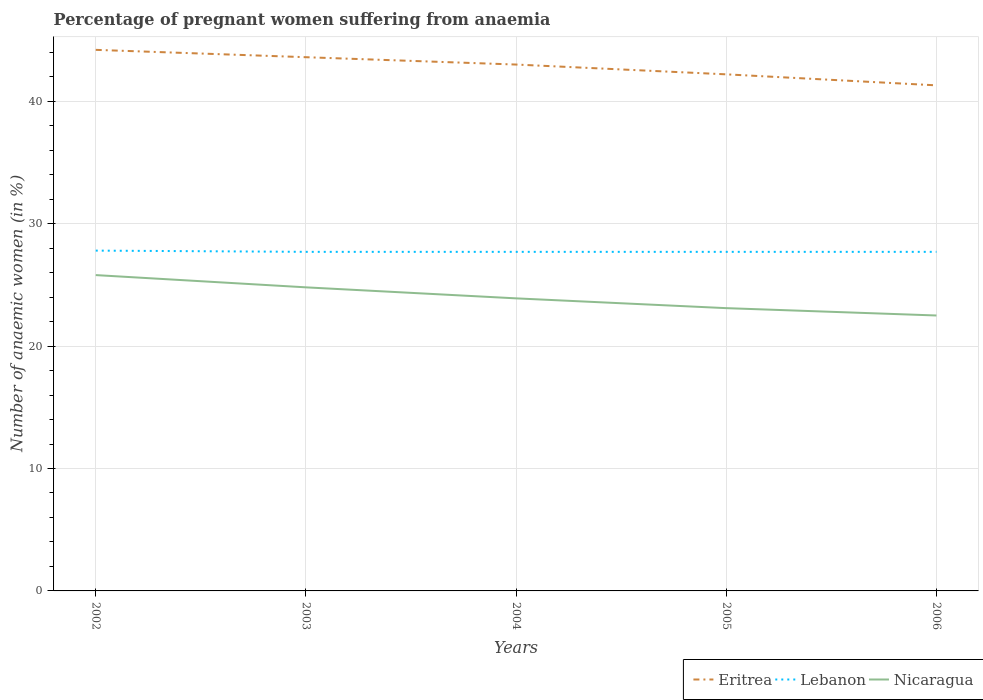Does the line corresponding to Nicaragua intersect with the line corresponding to Lebanon?
Your response must be concise. No. Is the number of lines equal to the number of legend labels?
Your answer should be very brief. Yes. Across all years, what is the maximum number of anaemic women in Eritrea?
Give a very brief answer. 41.3. In which year was the number of anaemic women in Nicaragua maximum?
Your response must be concise. 2006. What is the total number of anaemic women in Lebanon in the graph?
Give a very brief answer. 0.1. What is the difference between the highest and the second highest number of anaemic women in Lebanon?
Provide a short and direct response. 0.1. What is the difference between the highest and the lowest number of anaemic women in Lebanon?
Offer a terse response. 1. Is the number of anaemic women in Lebanon strictly greater than the number of anaemic women in Eritrea over the years?
Your answer should be compact. Yes. How many lines are there?
Ensure brevity in your answer.  3. How many legend labels are there?
Offer a very short reply. 3. What is the title of the graph?
Your response must be concise. Percentage of pregnant women suffering from anaemia. Does "Montenegro" appear as one of the legend labels in the graph?
Your answer should be compact. No. What is the label or title of the Y-axis?
Your response must be concise. Number of anaemic women (in %). What is the Number of anaemic women (in %) of Eritrea in 2002?
Offer a very short reply. 44.2. What is the Number of anaemic women (in %) in Lebanon in 2002?
Keep it short and to the point. 27.8. What is the Number of anaemic women (in %) of Nicaragua in 2002?
Give a very brief answer. 25.8. What is the Number of anaemic women (in %) in Eritrea in 2003?
Give a very brief answer. 43.6. What is the Number of anaemic women (in %) in Lebanon in 2003?
Provide a short and direct response. 27.7. What is the Number of anaemic women (in %) of Nicaragua in 2003?
Give a very brief answer. 24.8. What is the Number of anaemic women (in %) of Lebanon in 2004?
Offer a very short reply. 27.7. What is the Number of anaemic women (in %) in Nicaragua in 2004?
Offer a very short reply. 23.9. What is the Number of anaemic women (in %) of Eritrea in 2005?
Your answer should be compact. 42.2. What is the Number of anaemic women (in %) in Lebanon in 2005?
Your answer should be compact. 27.7. What is the Number of anaemic women (in %) in Nicaragua in 2005?
Provide a succinct answer. 23.1. What is the Number of anaemic women (in %) in Eritrea in 2006?
Ensure brevity in your answer.  41.3. What is the Number of anaemic women (in %) in Lebanon in 2006?
Your answer should be very brief. 27.7. What is the Number of anaemic women (in %) of Nicaragua in 2006?
Provide a short and direct response. 22.5. Across all years, what is the maximum Number of anaemic women (in %) of Eritrea?
Offer a very short reply. 44.2. Across all years, what is the maximum Number of anaemic women (in %) of Lebanon?
Your response must be concise. 27.8. Across all years, what is the maximum Number of anaemic women (in %) in Nicaragua?
Provide a succinct answer. 25.8. Across all years, what is the minimum Number of anaemic women (in %) in Eritrea?
Provide a succinct answer. 41.3. Across all years, what is the minimum Number of anaemic women (in %) of Lebanon?
Provide a short and direct response. 27.7. What is the total Number of anaemic women (in %) in Eritrea in the graph?
Offer a very short reply. 214.3. What is the total Number of anaemic women (in %) in Lebanon in the graph?
Provide a succinct answer. 138.6. What is the total Number of anaemic women (in %) of Nicaragua in the graph?
Keep it short and to the point. 120.1. What is the difference between the Number of anaemic women (in %) in Eritrea in 2002 and that in 2003?
Your answer should be compact. 0.6. What is the difference between the Number of anaemic women (in %) in Nicaragua in 2002 and that in 2003?
Your answer should be very brief. 1. What is the difference between the Number of anaemic women (in %) in Eritrea in 2002 and that in 2004?
Make the answer very short. 1.2. What is the difference between the Number of anaemic women (in %) of Nicaragua in 2002 and that in 2004?
Your response must be concise. 1.9. What is the difference between the Number of anaemic women (in %) of Nicaragua in 2002 and that in 2005?
Your response must be concise. 2.7. What is the difference between the Number of anaemic women (in %) in Eritrea in 2002 and that in 2006?
Keep it short and to the point. 2.9. What is the difference between the Number of anaemic women (in %) in Lebanon in 2002 and that in 2006?
Provide a short and direct response. 0.1. What is the difference between the Number of anaemic women (in %) in Nicaragua in 2002 and that in 2006?
Your answer should be very brief. 3.3. What is the difference between the Number of anaemic women (in %) of Eritrea in 2003 and that in 2004?
Offer a very short reply. 0.6. What is the difference between the Number of anaemic women (in %) in Nicaragua in 2003 and that in 2004?
Offer a very short reply. 0.9. What is the difference between the Number of anaemic women (in %) of Lebanon in 2003 and that in 2005?
Your answer should be very brief. 0. What is the difference between the Number of anaemic women (in %) of Nicaragua in 2004 and that in 2005?
Offer a terse response. 0.8. What is the difference between the Number of anaemic women (in %) of Eritrea in 2004 and that in 2006?
Give a very brief answer. 1.7. What is the difference between the Number of anaemic women (in %) of Lebanon in 2004 and that in 2006?
Your answer should be compact. 0. What is the difference between the Number of anaemic women (in %) of Eritrea in 2005 and that in 2006?
Provide a short and direct response. 0.9. What is the difference between the Number of anaemic women (in %) in Lebanon in 2005 and that in 2006?
Offer a terse response. 0. What is the difference between the Number of anaemic women (in %) in Nicaragua in 2005 and that in 2006?
Make the answer very short. 0.6. What is the difference between the Number of anaemic women (in %) in Eritrea in 2002 and the Number of anaemic women (in %) in Nicaragua in 2003?
Keep it short and to the point. 19.4. What is the difference between the Number of anaemic women (in %) in Lebanon in 2002 and the Number of anaemic women (in %) in Nicaragua in 2003?
Make the answer very short. 3. What is the difference between the Number of anaemic women (in %) in Eritrea in 2002 and the Number of anaemic women (in %) in Lebanon in 2004?
Your answer should be compact. 16.5. What is the difference between the Number of anaemic women (in %) of Eritrea in 2002 and the Number of anaemic women (in %) of Nicaragua in 2004?
Your response must be concise. 20.3. What is the difference between the Number of anaemic women (in %) of Lebanon in 2002 and the Number of anaemic women (in %) of Nicaragua in 2004?
Offer a very short reply. 3.9. What is the difference between the Number of anaemic women (in %) of Eritrea in 2002 and the Number of anaemic women (in %) of Nicaragua in 2005?
Your answer should be compact. 21.1. What is the difference between the Number of anaemic women (in %) in Lebanon in 2002 and the Number of anaemic women (in %) in Nicaragua in 2005?
Make the answer very short. 4.7. What is the difference between the Number of anaemic women (in %) of Eritrea in 2002 and the Number of anaemic women (in %) of Nicaragua in 2006?
Keep it short and to the point. 21.7. What is the difference between the Number of anaemic women (in %) of Lebanon in 2002 and the Number of anaemic women (in %) of Nicaragua in 2006?
Provide a succinct answer. 5.3. What is the difference between the Number of anaemic women (in %) in Eritrea in 2003 and the Number of anaemic women (in %) in Lebanon in 2004?
Give a very brief answer. 15.9. What is the difference between the Number of anaemic women (in %) in Eritrea in 2003 and the Number of anaemic women (in %) in Nicaragua in 2004?
Give a very brief answer. 19.7. What is the difference between the Number of anaemic women (in %) in Lebanon in 2003 and the Number of anaemic women (in %) in Nicaragua in 2004?
Offer a very short reply. 3.8. What is the difference between the Number of anaemic women (in %) in Eritrea in 2003 and the Number of anaemic women (in %) in Lebanon in 2005?
Your answer should be compact. 15.9. What is the difference between the Number of anaemic women (in %) in Lebanon in 2003 and the Number of anaemic women (in %) in Nicaragua in 2005?
Offer a terse response. 4.6. What is the difference between the Number of anaemic women (in %) in Eritrea in 2003 and the Number of anaemic women (in %) in Nicaragua in 2006?
Your answer should be compact. 21.1. What is the difference between the Number of anaemic women (in %) in Lebanon in 2003 and the Number of anaemic women (in %) in Nicaragua in 2006?
Provide a short and direct response. 5.2. What is the difference between the Number of anaemic women (in %) in Eritrea in 2004 and the Number of anaemic women (in %) in Lebanon in 2005?
Your answer should be compact. 15.3. What is the difference between the Number of anaemic women (in %) in Eritrea in 2004 and the Number of anaemic women (in %) in Nicaragua in 2005?
Keep it short and to the point. 19.9. What is the difference between the Number of anaemic women (in %) in Lebanon in 2005 and the Number of anaemic women (in %) in Nicaragua in 2006?
Your answer should be compact. 5.2. What is the average Number of anaemic women (in %) in Eritrea per year?
Your answer should be compact. 42.86. What is the average Number of anaemic women (in %) of Lebanon per year?
Your answer should be very brief. 27.72. What is the average Number of anaemic women (in %) of Nicaragua per year?
Your answer should be very brief. 24.02. In the year 2002, what is the difference between the Number of anaemic women (in %) in Eritrea and Number of anaemic women (in %) in Lebanon?
Offer a very short reply. 16.4. In the year 2002, what is the difference between the Number of anaemic women (in %) of Lebanon and Number of anaemic women (in %) of Nicaragua?
Provide a short and direct response. 2. In the year 2003, what is the difference between the Number of anaemic women (in %) in Eritrea and Number of anaemic women (in %) in Nicaragua?
Provide a succinct answer. 18.8. In the year 2003, what is the difference between the Number of anaemic women (in %) in Lebanon and Number of anaemic women (in %) in Nicaragua?
Your answer should be very brief. 2.9. In the year 2004, what is the difference between the Number of anaemic women (in %) of Lebanon and Number of anaemic women (in %) of Nicaragua?
Provide a succinct answer. 3.8. In the year 2006, what is the difference between the Number of anaemic women (in %) of Eritrea and Number of anaemic women (in %) of Lebanon?
Your response must be concise. 13.6. In the year 2006, what is the difference between the Number of anaemic women (in %) of Eritrea and Number of anaemic women (in %) of Nicaragua?
Offer a terse response. 18.8. What is the ratio of the Number of anaemic women (in %) of Eritrea in 2002 to that in 2003?
Make the answer very short. 1.01. What is the ratio of the Number of anaemic women (in %) of Nicaragua in 2002 to that in 2003?
Your answer should be compact. 1.04. What is the ratio of the Number of anaemic women (in %) of Eritrea in 2002 to that in 2004?
Make the answer very short. 1.03. What is the ratio of the Number of anaemic women (in %) in Lebanon in 2002 to that in 2004?
Offer a terse response. 1. What is the ratio of the Number of anaemic women (in %) in Nicaragua in 2002 to that in 2004?
Provide a short and direct response. 1.08. What is the ratio of the Number of anaemic women (in %) in Eritrea in 2002 to that in 2005?
Give a very brief answer. 1.05. What is the ratio of the Number of anaemic women (in %) in Nicaragua in 2002 to that in 2005?
Make the answer very short. 1.12. What is the ratio of the Number of anaemic women (in %) of Eritrea in 2002 to that in 2006?
Provide a short and direct response. 1.07. What is the ratio of the Number of anaemic women (in %) in Nicaragua in 2002 to that in 2006?
Your response must be concise. 1.15. What is the ratio of the Number of anaemic women (in %) of Lebanon in 2003 to that in 2004?
Offer a terse response. 1. What is the ratio of the Number of anaemic women (in %) in Nicaragua in 2003 to that in 2004?
Make the answer very short. 1.04. What is the ratio of the Number of anaemic women (in %) of Eritrea in 2003 to that in 2005?
Your response must be concise. 1.03. What is the ratio of the Number of anaemic women (in %) of Nicaragua in 2003 to that in 2005?
Offer a very short reply. 1.07. What is the ratio of the Number of anaemic women (in %) of Eritrea in 2003 to that in 2006?
Your answer should be compact. 1.06. What is the ratio of the Number of anaemic women (in %) of Nicaragua in 2003 to that in 2006?
Give a very brief answer. 1.1. What is the ratio of the Number of anaemic women (in %) of Nicaragua in 2004 to that in 2005?
Ensure brevity in your answer.  1.03. What is the ratio of the Number of anaemic women (in %) of Eritrea in 2004 to that in 2006?
Provide a short and direct response. 1.04. What is the ratio of the Number of anaemic women (in %) in Nicaragua in 2004 to that in 2006?
Keep it short and to the point. 1.06. What is the ratio of the Number of anaemic women (in %) in Eritrea in 2005 to that in 2006?
Provide a short and direct response. 1.02. What is the ratio of the Number of anaemic women (in %) of Nicaragua in 2005 to that in 2006?
Your answer should be very brief. 1.03. What is the difference between the highest and the second highest Number of anaemic women (in %) in Eritrea?
Make the answer very short. 0.6. What is the difference between the highest and the second highest Number of anaemic women (in %) in Nicaragua?
Offer a very short reply. 1. What is the difference between the highest and the lowest Number of anaemic women (in %) in Eritrea?
Your answer should be compact. 2.9. What is the difference between the highest and the lowest Number of anaemic women (in %) of Lebanon?
Ensure brevity in your answer.  0.1. What is the difference between the highest and the lowest Number of anaemic women (in %) of Nicaragua?
Keep it short and to the point. 3.3. 